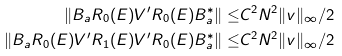<formula> <loc_0><loc_0><loc_500><loc_500>\| B _ { \L a } R _ { 0 } ( E ) V ^ { \prime } R _ { 0 } ( E ) B _ { \L a } ^ { * } \| \leq & C ^ { 2 } N ^ { 2 } \| v \| _ { \infty } / 2 \\ \| B _ { \L a } R _ { 0 } ( E ) V ^ { \prime } R _ { 1 } ( E ) V ^ { \prime } R _ { 0 } ( E ) B _ { \L a } ^ { * } \| \leq & C ^ { 2 } N ^ { 2 } \| v \| _ { \infty } / 2 \\</formula> 